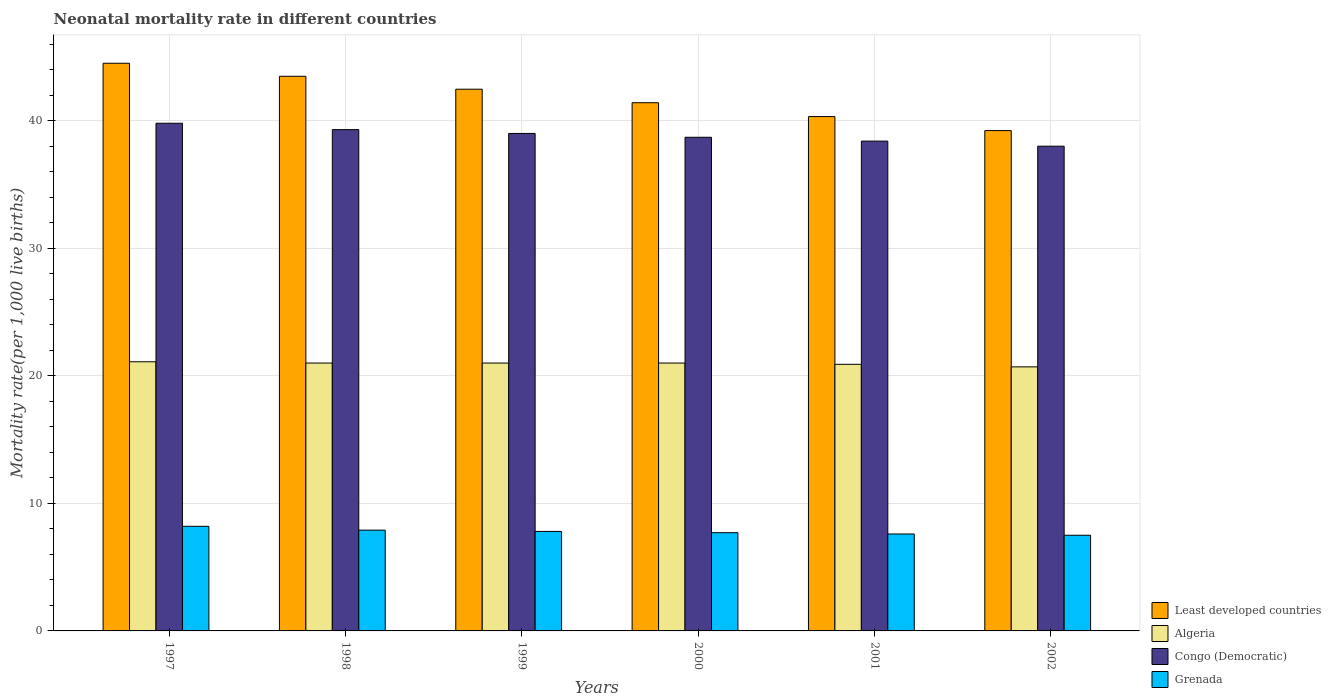How many groups of bars are there?
Your answer should be very brief. 6. Are the number of bars on each tick of the X-axis equal?
Offer a very short reply. Yes. In how many cases, is the number of bars for a given year not equal to the number of legend labels?
Provide a short and direct response. 0. Across all years, what is the minimum neonatal mortality rate in Least developed countries?
Provide a succinct answer. 39.22. In which year was the neonatal mortality rate in Algeria minimum?
Provide a succinct answer. 2002. What is the total neonatal mortality rate in Grenada in the graph?
Your answer should be compact. 46.7. What is the difference between the neonatal mortality rate in Congo (Democratic) in 2001 and that in 2002?
Ensure brevity in your answer.  0.4. What is the difference between the neonatal mortality rate in Congo (Democratic) in 2000 and the neonatal mortality rate in Least developed countries in 1997?
Offer a terse response. -5.8. What is the average neonatal mortality rate in Congo (Democratic) per year?
Your answer should be very brief. 38.87. In the year 2001, what is the difference between the neonatal mortality rate in Least developed countries and neonatal mortality rate in Algeria?
Make the answer very short. 19.42. In how many years, is the neonatal mortality rate in Algeria greater than 6?
Ensure brevity in your answer.  6. What is the ratio of the neonatal mortality rate in Congo (Democratic) in 1999 to that in 2000?
Provide a short and direct response. 1.01. Is the neonatal mortality rate in Least developed countries in 1997 less than that in 2000?
Provide a succinct answer. No. Is the difference between the neonatal mortality rate in Least developed countries in 2000 and 2001 greater than the difference between the neonatal mortality rate in Algeria in 2000 and 2001?
Keep it short and to the point. Yes. What is the difference between the highest and the second highest neonatal mortality rate in Algeria?
Keep it short and to the point. 0.1. What is the difference between the highest and the lowest neonatal mortality rate in Least developed countries?
Provide a succinct answer. 5.28. In how many years, is the neonatal mortality rate in Grenada greater than the average neonatal mortality rate in Grenada taken over all years?
Give a very brief answer. 3. What does the 3rd bar from the left in 1998 represents?
Give a very brief answer. Congo (Democratic). What does the 1st bar from the right in 1998 represents?
Ensure brevity in your answer.  Grenada. Are all the bars in the graph horizontal?
Provide a succinct answer. No. Does the graph contain any zero values?
Ensure brevity in your answer.  No. What is the title of the graph?
Your response must be concise. Neonatal mortality rate in different countries. What is the label or title of the X-axis?
Your response must be concise. Years. What is the label or title of the Y-axis?
Offer a terse response. Mortality rate(per 1,0 live births). What is the Mortality rate(per 1,000 live births) in Least developed countries in 1997?
Make the answer very short. 44.5. What is the Mortality rate(per 1,000 live births) of Algeria in 1997?
Your response must be concise. 21.1. What is the Mortality rate(per 1,000 live births) of Congo (Democratic) in 1997?
Your response must be concise. 39.8. What is the Mortality rate(per 1,000 live births) of Least developed countries in 1998?
Give a very brief answer. 43.48. What is the Mortality rate(per 1,000 live births) in Congo (Democratic) in 1998?
Provide a short and direct response. 39.3. What is the Mortality rate(per 1,000 live births) of Least developed countries in 1999?
Your response must be concise. 42.47. What is the Mortality rate(per 1,000 live births) in Least developed countries in 2000?
Make the answer very short. 41.41. What is the Mortality rate(per 1,000 live births) of Congo (Democratic) in 2000?
Offer a very short reply. 38.7. What is the Mortality rate(per 1,000 live births) of Least developed countries in 2001?
Ensure brevity in your answer.  40.32. What is the Mortality rate(per 1,000 live births) of Algeria in 2001?
Make the answer very short. 20.9. What is the Mortality rate(per 1,000 live births) in Congo (Democratic) in 2001?
Keep it short and to the point. 38.4. What is the Mortality rate(per 1,000 live births) of Grenada in 2001?
Ensure brevity in your answer.  7.6. What is the Mortality rate(per 1,000 live births) in Least developed countries in 2002?
Make the answer very short. 39.22. What is the Mortality rate(per 1,000 live births) in Algeria in 2002?
Make the answer very short. 20.7. What is the Mortality rate(per 1,000 live births) in Congo (Democratic) in 2002?
Offer a terse response. 38. Across all years, what is the maximum Mortality rate(per 1,000 live births) of Least developed countries?
Your response must be concise. 44.5. Across all years, what is the maximum Mortality rate(per 1,000 live births) in Algeria?
Provide a succinct answer. 21.1. Across all years, what is the maximum Mortality rate(per 1,000 live births) in Congo (Democratic)?
Provide a succinct answer. 39.8. Across all years, what is the maximum Mortality rate(per 1,000 live births) of Grenada?
Provide a short and direct response. 8.2. Across all years, what is the minimum Mortality rate(per 1,000 live births) in Least developed countries?
Ensure brevity in your answer.  39.22. Across all years, what is the minimum Mortality rate(per 1,000 live births) of Algeria?
Make the answer very short. 20.7. Across all years, what is the minimum Mortality rate(per 1,000 live births) of Grenada?
Provide a succinct answer. 7.5. What is the total Mortality rate(per 1,000 live births) of Least developed countries in the graph?
Offer a very short reply. 251.4. What is the total Mortality rate(per 1,000 live births) in Algeria in the graph?
Keep it short and to the point. 125.7. What is the total Mortality rate(per 1,000 live births) of Congo (Democratic) in the graph?
Ensure brevity in your answer.  233.2. What is the total Mortality rate(per 1,000 live births) in Grenada in the graph?
Your answer should be very brief. 46.7. What is the difference between the Mortality rate(per 1,000 live births) in Congo (Democratic) in 1997 and that in 1998?
Your response must be concise. 0.5. What is the difference between the Mortality rate(per 1,000 live births) of Grenada in 1997 and that in 1998?
Give a very brief answer. 0.3. What is the difference between the Mortality rate(per 1,000 live births) of Least developed countries in 1997 and that in 1999?
Your response must be concise. 2.03. What is the difference between the Mortality rate(per 1,000 live births) of Algeria in 1997 and that in 1999?
Make the answer very short. 0.1. What is the difference between the Mortality rate(per 1,000 live births) of Congo (Democratic) in 1997 and that in 1999?
Ensure brevity in your answer.  0.8. What is the difference between the Mortality rate(per 1,000 live births) of Least developed countries in 1997 and that in 2000?
Provide a succinct answer. 3.09. What is the difference between the Mortality rate(per 1,000 live births) in Grenada in 1997 and that in 2000?
Provide a succinct answer. 0.5. What is the difference between the Mortality rate(per 1,000 live births) of Least developed countries in 1997 and that in 2001?
Offer a terse response. 4.18. What is the difference between the Mortality rate(per 1,000 live births) of Congo (Democratic) in 1997 and that in 2001?
Provide a succinct answer. 1.4. What is the difference between the Mortality rate(per 1,000 live births) in Least developed countries in 1997 and that in 2002?
Make the answer very short. 5.28. What is the difference between the Mortality rate(per 1,000 live births) in Congo (Democratic) in 1997 and that in 2002?
Offer a very short reply. 1.8. What is the difference between the Mortality rate(per 1,000 live births) in Least developed countries in 1998 and that in 1999?
Your answer should be compact. 1.01. What is the difference between the Mortality rate(per 1,000 live births) of Algeria in 1998 and that in 1999?
Keep it short and to the point. 0. What is the difference between the Mortality rate(per 1,000 live births) in Congo (Democratic) in 1998 and that in 1999?
Your answer should be compact. 0.3. What is the difference between the Mortality rate(per 1,000 live births) in Grenada in 1998 and that in 1999?
Offer a very short reply. 0.1. What is the difference between the Mortality rate(per 1,000 live births) of Least developed countries in 1998 and that in 2000?
Make the answer very short. 2.07. What is the difference between the Mortality rate(per 1,000 live births) in Congo (Democratic) in 1998 and that in 2000?
Ensure brevity in your answer.  0.6. What is the difference between the Mortality rate(per 1,000 live births) in Least developed countries in 1998 and that in 2001?
Provide a succinct answer. 3.16. What is the difference between the Mortality rate(per 1,000 live births) in Algeria in 1998 and that in 2001?
Ensure brevity in your answer.  0.1. What is the difference between the Mortality rate(per 1,000 live births) in Grenada in 1998 and that in 2001?
Your response must be concise. 0.3. What is the difference between the Mortality rate(per 1,000 live births) of Least developed countries in 1998 and that in 2002?
Keep it short and to the point. 4.26. What is the difference between the Mortality rate(per 1,000 live births) of Congo (Democratic) in 1998 and that in 2002?
Ensure brevity in your answer.  1.3. What is the difference between the Mortality rate(per 1,000 live births) in Least developed countries in 1999 and that in 2000?
Provide a succinct answer. 1.06. What is the difference between the Mortality rate(per 1,000 live births) in Congo (Democratic) in 1999 and that in 2000?
Your answer should be compact. 0.3. What is the difference between the Mortality rate(per 1,000 live births) of Grenada in 1999 and that in 2000?
Keep it short and to the point. 0.1. What is the difference between the Mortality rate(per 1,000 live births) in Least developed countries in 1999 and that in 2001?
Provide a succinct answer. 2.15. What is the difference between the Mortality rate(per 1,000 live births) of Congo (Democratic) in 1999 and that in 2001?
Make the answer very short. 0.6. What is the difference between the Mortality rate(per 1,000 live births) in Least developed countries in 1999 and that in 2002?
Offer a terse response. 3.24. What is the difference between the Mortality rate(per 1,000 live births) of Algeria in 1999 and that in 2002?
Your answer should be compact. 0.3. What is the difference between the Mortality rate(per 1,000 live births) in Congo (Democratic) in 1999 and that in 2002?
Ensure brevity in your answer.  1. What is the difference between the Mortality rate(per 1,000 live births) in Least developed countries in 2000 and that in 2001?
Make the answer very short. 1.09. What is the difference between the Mortality rate(per 1,000 live births) in Grenada in 2000 and that in 2001?
Provide a short and direct response. 0.1. What is the difference between the Mortality rate(per 1,000 live births) in Least developed countries in 2000 and that in 2002?
Ensure brevity in your answer.  2.19. What is the difference between the Mortality rate(per 1,000 live births) of Algeria in 2000 and that in 2002?
Provide a succinct answer. 0.3. What is the difference between the Mortality rate(per 1,000 live births) of Congo (Democratic) in 2000 and that in 2002?
Provide a succinct answer. 0.7. What is the difference between the Mortality rate(per 1,000 live births) in Grenada in 2000 and that in 2002?
Ensure brevity in your answer.  0.2. What is the difference between the Mortality rate(per 1,000 live births) in Least developed countries in 2001 and that in 2002?
Provide a succinct answer. 1.1. What is the difference between the Mortality rate(per 1,000 live births) of Least developed countries in 1997 and the Mortality rate(per 1,000 live births) of Algeria in 1998?
Make the answer very short. 23.5. What is the difference between the Mortality rate(per 1,000 live births) in Least developed countries in 1997 and the Mortality rate(per 1,000 live births) in Congo (Democratic) in 1998?
Provide a succinct answer. 5.2. What is the difference between the Mortality rate(per 1,000 live births) in Least developed countries in 1997 and the Mortality rate(per 1,000 live births) in Grenada in 1998?
Provide a succinct answer. 36.6. What is the difference between the Mortality rate(per 1,000 live births) in Algeria in 1997 and the Mortality rate(per 1,000 live births) in Congo (Democratic) in 1998?
Your answer should be compact. -18.2. What is the difference between the Mortality rate(per 1,000 live births) in Algeria in 1997 and the Mortality rate(per 1,000 live births) in Grenada in 1998?
Your answer should be very brief. 13.2. What is the difference between the Mortality rate(per 1,000 live births) of Congo (Democratic) in 1997 and the Mortality rate(per 1,000 live births) of Grenada in 1998?
Offer a very short reply. 31.9. What is the difference between the Mortality rate(per 1,000 live births) in Least developed countries in 1997 and the Mortality rate(per 1,000 live births) in Algeria in 1999?
Ensure brevity in your answer.  23.5. What is the difference between the Mortality rate(per 1,000 live births) in Least developed countries in 1997 and the Mortality rate(per 1,000 live births) in Congo (Democratic) in 1999?
Offer a terse response. 5.5. What is the difference between the Mortality rate(per 1,000 live births) in Least developed countries in 1997 and the Mortality rate(per 1,000 live births) in Grenada in 1999?
Provide a short and direct response. 36.7. What is the difference between the Mortality rate(per 1,000 live births) of Algeria in 1997 and the Mortality rate(per 1,000 live births) of Congo (Democratic) in 1999?
Your answer should be very brief. -17.9. What is the difference between the Mortality rate(per 1,000 live births) of Algeria in 1997 and the Mortality rate(per 1,000 live births) of Grenada in 1999?
Keep it short and to the point. 13.3. What is the difference between the Mortality rate(per 1,000 live births) of Least developed countries in 1997 and the Mortality rate(per 1,000 live births) of Algeria in 2000?
Make the answer very short. 23.5. What is the difference between the Mortality rate(per 1,000 live births) in Least developed countries in 1997 and the Mortality rate(per 1,000 live births) in Congo (Democratic) in 2000?
Offer a very short reply. 5.8. What is the difference between the Mortality rate(per 1,000 live births) in Least developed countries in 1997 and the Mortality rate(per 1,000 live births) in Grenada in 2000?
Provide a succinct answer. 36.8. What is the difference between the Mortality rate(per 1,000 live births) in Algeria in 1997 and the Mortality rate(per 1,000 live births) in Congo (Democratic) in 2000?
Offer a very short reply. -17.6. What is the difference between the Mortality rate(per 1,000 live births) in Algeria in 1997 and the Mortality rate(per 1,000 live births) in Grenada in 2000?
Provide a short and direct response. 13.4. What is the difference between the Mortality rate(per 1,000 live births) of Congo (Democratic) in 1997 and the Mortality rate(per 1,000 live births) of Grenada in 2000?
Keep it short and to the point. 32.1. What is the difference between the Mortality rate(per 1,000 live births) of Least developed countries in 1997 and the Mortality rate(per 1,000 live births) of Algeria in 2001?
Give a very brief answer. 23.6. What is the difference between the Mortality rate(per 1,000 live births) in Least developed countries in 1997 and the Mortality rate(per 1,000 live births) in Congo (Democratic) in 2001?
Your answer should be compact. 6.1. What is the difference between the Mortality rate(per 1,000 live births) of Least developed countries in 1997 and the Mortality rate(per 1,000 live births) of Grenada in 2001?
Your response must be concise. 36.9. What is the difference between the Mortality rate(per 1,000 live births) of Algeria in 1997 and the Mortality rate(per 1,000 live births) of Congo (Democratic) in 2001?
Give a very brief answer. -17.3. What is the difference between the Mortality rate(per 1,000 live births) in Algeria in 1997 and the Mortality rate(per 1,000 live births) in Grenada in 2001?
Give a very brief answer. 13.5. What is the difference between the Mortality rate(per 1,000 live births) in Congo (Democratic) in 1997 and the Mortality rate(per 1,000 live births) in Grenada in 2001?
Your answer should be very brief. 32.2. What is the difference between the Mortality rate(per 1,000 live births) in Least developed countries in 1997 and the Mortality rate(per 1,000 live births) in Algeria in 2002?
Your answer should be very brief. 23.8. What is the difference between the Mortality rate(per 1,000 live births) in Least developed countries in 1997 and the Mortality rate(per 1,000 live births) in Congo (Democratic) in 2002?
Provide a succinct answer. 6.5. What is the difference between the Mortality rate(per 1,000 live births) of Least developed countries in 1997 and the Mortality rate(per 1,000 live births) of Grenada in 2002?
Offer a terse response. 37. What is the difference between the Mortality rate(per 1,000 live births) of Algeria in 1997 and the Mortality rate(per 1,000 live births) of Congo (Democratic) in 2002?
Make the answer very short. -16.9. What is the difference between the Mortality rate(per 1,000 live births) in Algeria in 1997 and the Mortality rate(per 1,000 live births) in Grenada in 2002?
Provide a succinct answer. 13.6. What is the difference between the Mortality rate(per 1,000 live births) in Congo (Democratic) in 1997 and the Mortality rate(per 1,000 live births) in Grenada in 2002?
Your answer should be very brief. 32.3. What is the difference between the Mortality rate(per 1,000 live births) of Least developed countries in 1998 and the Mortality rate(per 1,000 live births) of Algeria in 1999?
Provide a short and direct response. 22.48. What is the difference between the Mortality rate(per 1,000 live births) of Least developed countries in 1998 and the Mortality rate(per 1,000 live births) of Congo (Democratic) in 1999?
Your answer should be very brief. 4.48. What is the difference between the Mortality rate(per 1,000 live births) in Least developed countries in 1998 and the Mortality rate(per 1,000 live births) in Grenada in 1999?
Your answer should be very brief. 35.68. What is the difference between the Mortality rate(per 1,000 live births) in Algeria in 1998 and the Mortality rate(per 1,000 live births) in Grenada in 1999?
Provide a short and direct response. 13.2. What is the difference between the Mortality rate(per 1,000 live births) in Congo (Democratic) in 1998 and the Mortality rate(per 1,000 live births) in Grenada in 1999?
Make the answer very short. 31.5. What is the difference between the Mortality rate(per 1,000 live births) of Least developed countries in 1998 and the Mortality rate(per 1,000 live births) of Algeria in 2000?
Keep it short and to the point. 22.48. What is the difference between the Mortality rate(per 1,000 live births) in Least developed countries in 1998 and the Mortality rate(per 1,000 live births) in Congo (Democratic) in 2000?
Offer a very short reply. 4.78. What is the difference between the Mortality rate(per 1,000 live births) of Least developed countries in 1998 and the Mortality rate(per 1,000 live births) of Grenada in 2000?
Provide a succinct answer. 35.78. What is the difference between the Mortality rate(per 1,000 live births) of Algeria in 1998 and the Mortality rate(per 1,000 live births) of Congo (Democratic) in 2000?
Give a very brief answer. -17.7. What is the difference between the Mortality rate(per 1,000 live births) of Algeria in 1998 and the Mortality rate(per 1,000 live births) of Grenada in 2000?
Ensure brevity in your answer.  13.3. What is the difference between the Mortality rate(per 1,000 live births) in Congo (Democratic) in 1998 and the Mortality rate(per 1,000 live births) in Grenada in 2000?
Your answer should be very brief. 31.6. What is the difference between the Mortality rate(per 1,000 live births) of Least developed countries in 1998 and the Mortality rate(per 1,000 live births) of Algeria in 2001?
Your answer should be very brief. 22.58. What is the difference between the Mortality rate(per 1,000 live births) of Least developed countries in 1998 and the Mortality rate(per 1,000 live births) of Congo (Democratic) in 2001?
Your answer should be very brief. 5.08. What is the difference between the Mortality rate(per 1,000 live births) in Least developed countries in 1998 and the Mortality rate(per 1,000 live births) in Grenada in 2001?
Your response must be concise. 35.88. What is the difference between the Mortality rate(per 1,000 live births) in Algeria in 1998 and the Mortality rate(per 1,000 live births) in Congo (Democratic) in 2001?
Provide a succinct answer. -17.4. What is the difference between the Mortality rate(per 1,000 live births) in Congo (Democratic) in 1998 and the Mortality rate(per 1,000 live births) in Grenada in 2001?
Your answer should be compact. 31.7. What is the difference between the Mortality rate(per 1,000 live births) in Least developed countries in 1998 and the Mortality rate(per 1,000 live births) in Algeria in 2002?
Offer a terse response. 22.78. What is the difference between the Mortality rate(per 1,000 live births) in Least developed countries in 1998 and the Mortality rate(per 1,000 live births) in Congo (Democratic) in 2002?
Your answer should be very brief. 5.48. What is the difference between the Mortality rate(per 1,000 live births) in Least developed countries in 1998 and the Mortality rate(per 1,000 live births) in Grenada in 2002?
Your response must be concise. 35.98. What is the difference between the Mortality rate(per 1,000 live births) in Congo (Democratic) in 1998 and the Mortality rate(per 1,000 live births) in Grenada in 2002?
Your answer should be compact. 31.8. What is the difference between the Mortality rate(per 1,000 live births) of Least developed countries in 1999 and the Mortality rate(per 1,000 live births) of Algeria in 2000?
Give a very brief answer. 21.47. What is the difference between the Mortality rate(per 1,000 live births) in Least developed countries in 1999 and the Mortality rate(per 1,000 live births) in Congo (Democratic) in 2000?
Provide a succinct answer. 3.77. What is the difference between the Mortality rate(per 1,000 live births) of Least developed countries in 1999 and the Mortality rate(per 1,000 live births) of Grenada in 2000?
Provide a succinct answer. 34.77. What is the difference between the Mortality rate(per 1,000 live births) in Algeria in 1999 and the Mortality rate(per 1,000 live births) in Congo (Democratic) in 2000?
Give a very brief answer. -17.7. What is the difference between the Mortality rate(per 1,000 live births) in Congo (Democratic) in 1999 and the Mortality rate(per 1,000 live births) in Grenada in 2000?
Offer a terse response. 31.3. What is the difference between the Mortality rate(per 1,000 live births) in Least developed countries in 1999 and the Mortality rate(per 1,000 live births) in Algeria in 2001?
Make the answer very short. 21.57. What is the difference between the Mortality rate(per 1,000 live births) of Least developed countries in 1999 and the Mortality rate(per 1,000 live births) of Congo (Democratic) in 2001?
Ensure brevity in your answer.  4.07. What is the difference between the Mortality rate(per 1,000 live births) in Least developed countries in 1999 and the Mortality rate(per 1,000 live births) in Grenada in 2001?
Provide a succinct answer. 34.87. What is the difference between the Mortality rate(per 1,000 live births) in Algeria in 1999 and the Mortality rate(per 1,000 live births) in Congo (Democratic) in 2001?
Make the answer very short. -17.4. What is the difference between the Mortality rate(per 1,000 live births) in Algeria in 1999 and the Mortality rate(per 1,000 live births) in Grenada in 2001?
Your answer should be compact. 13.4. What is the difference between the Mortality rate(per 1,000 live births) in Congo (Democratic) in 1999 and the Mortality rate(per 1,000 live births) in Grenada in 2001?
Your answer should be compact. 31.4. What is the difference between the Mortality rate(per 1,000 live births) of Least developed countries in 1999 and the Mortality rate(per 1,000 live births) of Algeria in 2002?
Provide a succinct answer. 21.77. What is the difference between the Mortality rate(per 1,000 live births) in Least developed countries in 1999 and the Mortality rate(per 1,000 live births) in Congo (Democratic) in 2002?
Offer a very short reply. 4.47. What is the difference between the Mortality rate(per 1,000 live births) of Least developed countries in 1999 and the Mortality rate(per 1,000 live births) of Grenada in 2002?
Ensure brevity in your answer.  34.97. What is the difference between the Mortality rate(per 1,000 live births) in Algeria in 1999 and the Mortality rate(per 1,000 live births) in Congo (Democratic) in 2002?
Provide a succinct answer. -17. What is the difference between the Mortality rate(per 1,000 live births) of Algeria in 1999 and the Mortality rate(per 1,000 live births) of Grenada in 2002?
Offer a terse response. 13.5. What is the difference between the Mortality rate(per 1,000 live births) in Congo (Democratic) in 1999 and the Mortality rate(per 1,000 live births) in Grenada in 2002?
Make the answer very short. 31.5. What is the difference between the Mortality rate(per 1,000 live births) of Least developed countries in 2000 and the Mortality rate(per 1,000 live births) of Algeria in 2001?
Your answer should be very brief. 20.51. What is the difference between the Mortality rate(per 1,000 live births) of Least developed countries in 2000 and the Mortality rate(per 1,000 live births) of Congo (Democratic) in 2001?
Provide a short and direct response. 3.01. What is the difference between the Mortality rate(per 1,000 live births) of Least developed countries in 2000 and the Mortality rate(per 1,000 live births) of Grenada in 2001?
Offer a terse response. 33.81. What is the difference between the Mortality rate(per 1,000 live births) of Algeria in 2000 and the Mortality rate(per 1,000 live births) of Congo (Democratic) in 2001?
Keep it short and to the point. -17.4. What is the difference between the Mortality rate(per 1,000 live births) in Congo (Democratic) in 2000 and the Mortality rate(per 1,000 live births) in Grenada in 2001?
Keep it short and to the point. 31.1. What is the difference between the Mortality rate(per 1,000 live births) of Least developed countries in 2000 and the Mortality rate(per 1,000 live births) of Algeria in 2002?
Your answer should be compact. 20.71. What is the difference between the Mortality rate(per 1,000 live births) in Least developed countries in 2000 and the Mortality rate(per 1,000 live births) in Congo (Democratic) in 2002?
Keep it short and to the point. 3.41. What is the difference between the Mortality rate(per 1,000 live births) in Least developed countries in 2000 and the Mortality rate(per 1,000 live births) in Grenada in 2002?
Ensure brevity in your answer.  33.91. What is the difference between the Mortality rate(per 1,000 live births) in Algeria in 2000 and the Mortality rate(per 1,000 live births) in Grenada in 2002?
Offer a very short reply. 13.5. What is the difference between the Mortality rate(per 1,000 live births) of Congo (Democratic) in 2000 and the Mortality rate(per 1,000 live births) of Grenada in 2002?
Ensure brevity in your answer.  31.2. What is the difference between the Mortality rate(per 1,000 live births) in Least developed countries in 2001 and the Mortality rate(per 1,000 live births) in Algeria in 2002?
Your answer should be compact. 19.62. What is the difference between the Mortality rate(per 1,000 live births) in Least developed countries in 2001 and the Mortality rate(per 1,000 live births) in Congo (Democratic) in 2002?
Ensure brevity in your answer.  2.32. What is the difference between the Mortality rate(per 1,000 live births) in Least developed countries in 2001 and the Mortality rate(per 1,000 live births) in Grenada in 2002?
Offer a very short reply. 32.82. What is the difference between the Mortality rate(per 1,000 live births) in Algeria in 2001 and the Mortality rate(per 1,000 live births) in Congo (Democratic) in 2002?
Your response must be concise. -17.1. What is the difference between the Mortality rate(per 1,000 live births) in Algeria in 2001 and the Mortality rate(per 1,000 live births) in Grenada in 2002?
Give a very brief answer. 13.4. What is the difference between the Mortality rate(per 1,000 live births) in Congo (Democratic) in 2001 and the Mortality rate(per 1,000 live births) in Grenada in 2002?
Keep it short and to the point. 30.9. What is the average Mortality rate(per 1,000 live births) of Least developed countries per year?
Offer a terse response. 41.9. What is the average Mortality rate(per 1,000 live births) of Algeria per year?
Provide a succinct answer. 20.95. What is the average Mortality rate(per 1,000 live births) in Congo (Democratic) per year?
Offer a terse response. 38.87. What is the average Mortality rate(per 1,000 live births) of Grenada per year?
Ensure brevity in your answer.  7.78. In the year 1997, what is the difference between the Mortality rate(per 1,000 live births) in Least developed countries and Mortality rate(per 1,000 live births) in Algeria?
Your response must be concise. 23.4. In the year 1997, what is the difference between the Mortality rate(per 1,000 live births) of Least developed countries and Mortality rate(per 1,000 live births) of Congo (Democratic)?
Your response must be concise. 4.7. In the year 1997, what is the difference between the Mortality rate(per 1,000 live births) in Least developed countries and Mortality rate(per 1,000 live births) in Grenada?
Keep it short and to the point. 36.3. In the year 1997, what is the difference between the Mortality rate(per 1,000 live births) in Algeria and Mortality rate(per 1,000 live births) in Congo (Democratic)?
Give a very brief answer. -18.7. In the year 1997, what is the difference between the Mortality rate(per 1,000 live births) of Algeria and Mortality rate(per 1,000 live births) of Grenada?
Provide a short and direct response. 12.9. In the year 1997, what is the difference between the Mortality rate(per 1,000 live births) of Congo (Democratic) and Mortality rate(per 1,000 live births) of Grenada?
Give a very brief answer. 31.6. In the year 1998, what is the difference between the Mortality rate(per 1,000 live births) of Least developed countries and Mortality rate(per 1,000 live births) of Algeria?
Make the answer very short. 22.48. In the year 1998, what is the difference between the Mortality rate(per 1,000 live births) in Least developed countries and Mortality rate(per 1,000 live births) in Congo (Democratic)?
Give a very brief answer. 4.18. In the year 1998, what is the difference between the Mortality rate(per 1,000 live births) in Least developed countries and Mortality rate(per 1,000 live births) in Grenada?
Your response must be concise. 35.58. In the year 1998, what is the difference between the Mortality rate(per 1,000 live births) in Algeria and Mortality rate(per 1,000 live births) in Congo (Democratic)?
Keep it short and to the point. -18.3. In the year 1998, what is the difference between the Mortality rate(per 1,000 live births) in Congo (Democratic) and Mortality rate(per 1,000 live births) in Grenada?
Ensure brevity in your answer.  31.4. In the year 1999, what is the difference between the Mortality rate(per 1,000 live births) of Least developed countries and Mortality rate(per 1,000 live births) of Algeria?
Provide a succinct answer. 21.47. In the year 1999, what is the difference between the Mortality rate(per 1,000 live births) of Least developed countries and Mortality rate(per 1,000 live births) of Congo (Democratic)?
Your answer should be compact. 3.47. In the year 1999, what is the difference between the Mortality rate(per 1,000 live births) in Least developed countries and Mortality rate(per 1,000 live births) in Grenada?
Offer a terse response. 34.67. In the year 1999, what is the difference between the Mortality rate(per 1,000 live births) in Algeria and Mortality rate(per 1,000 live births) in Congo (Democratic)?
Offer a very short reply. -18. In the year 1999, what is the difference between the Mortality rate(per 1,000 live births) in Congo (Democratic) and Mortality rate(per 1,000 live births) in Grenada?
Provide a short and direct response. 31.2. In the year 2000, what is the difference between the Mortality rate(per 1,000 live births) of Least developed countries and Mortality rate(per 1,000 live births) of Algeria?
Offer a terse response. 20.41. In the year 2000, what is the difference between the Mortality rate(per 1,000 live births) in Least developed countries and Mortality rate(per 1,000 live births) in Congo (Democratic)?
Offer a terse response. 2.71. In the year 2000, what is the difference between the Mortality rate(per 1,000 live births) in Least developed countries and Mortality rate(per 1,000 live births) in Grenada?
Your answer should be very brief. 33.71. In the year 2000, what is the difference between the Mortality rate(per 1,000 live births) in Algeria and Mortality rate(per 1,000 live births) in Congo (Democratic)?
Give a very brief answer. -17.7. In the year 2001, what is the difference between the Mortality rate(per 1,000 live births) of Least developed countries and Mortality rate(per 1,000 live births) of Algeria?
Ensure brevity in your answer.  19.42. In the year 2001, what is the difference between the Mortality rate(per 1,000 live births) of Least developed countries and Mortality rate(per 1,000 live births) of Congo (Democratic)?
Your response must be concise. 1.92. In the year 2001, what is the difference between the Mortality rate(per 1,000 live births) in Least developed countries and Mortality rate(per 1,000 live births) in Grenada?
Your answer should be compact. 32.72. In the year 2001, what is the difference between the Mortality rate(per 1,000 live births) of Algeria and Mortality rate(per 1,000 live births) of Congo (Democratic)?
Make the answer very short. -17.5. In the year 2001, what is the difference between the Mortality rate(per 1,000 live births) of Algeria and Mortality rate(per 1,000 live births) of Grenada?
Offer a terse response. 13.3. In the year 2001, what is the difference between the Mortality rate(per 1,000 live births) of Congo (Democratic) and Mortality rate(per 1,000 live births) of Grenada?
Your response must be concise. 30.8. In the year 2002, what is the difference between the Mortality rate(per 1,000 live births) of Least developed countries and Mortality rate(per 1,000 live births) of Algeria?
Give a very brief answer. 18.52. In the year 2002, what is the difference between the Mortality rate(per 1,000 live births) of Least developed countries and Mortality rate(per 1,000 live births) of Congo (Democratic)?
Your answer should be very brief. 1.22. In the year 2002, what is the difference between the Mortality rate(per 1,000 live births) in Least developed countries and Mortality rate(per 1,000 live births) in Grenada?
Ensure brevity in your answer.  31.72. In the year 2002, what is the difference between the Mortality rate(per 1,000 live births) of Algeria and Mortality rate(per 1,000 live births) of Congo (Democratic)?
Offer a terse response. -17.3. In the year 2002, what is the difference between the Mortality rate(per 1,000 live births) in Algeria and Mortality rate(per 1,000 live births) in Grenada?
Give a very brief answer. 13.2. In the year 2002, what is the difference between the Mortality rate(per 1,000 live births) in Congo (Democratic) and Mortality rate(per 1,000 live births) in Grenada?
Offer a very short reply. 30.5. What is the ratio of the Mortality rate(per 1,000 live births) in Least developed countries in 1997 to that in 1998?
Keep it short and to the point. 1.02. What is the ratio of the Mortality rate(per 1,000 live births) of Congo (Democratic) in 1997 to that in 1998?
Give a very brief answer. 1.01. What is the ratio of the Mortality rate(per 1,000 live births) of Grenada in 1997 to that in 1998?
Offer a terse response. 1.04. What is the ratio of the Mortality rate(per 1,000 live births) of Least developed countries in 1997 to that in 1999?
Provide a succinct answer. 1.05. What is the ratio of the Mortality rate(per 1,000 live births) in Algeria in 1997 to that in 1999?
Provide a short and direct response. 1. What is the ratio of the Mortality rate(per 1,000 live births) in Congo (Democratic) in 1997 to that in 1999?
Your answer should be compact. 1.02. What is the ratio of the Mortality rate(per 1,000 live births) of Grenada in 1997 to that in 1999?
Your answer should be compact. 1.05. What is the ratio of the Mortality rate(per 1,000 live births) of Least developed countries in 1997 to that in 2000?
Make the answer very short. 1.07. What is the ratio of the Mortality rate(per 1,000 live births) of Congo (Democratic) in 1997 to that in 2000?
Your response must be concise. 1.03. What is the ratio of the Mortality rate(per 1,000 live births) in Grenada in 1997 to that in 2000?
Make the answer very short. 1.06. What is the ratio of the Mortality rate(per 1,000 live births) of Least developed countries in 1997 to that in 2001?
Make the answer very short. 1.1. What is the ratio of the Mortality rate(per 1,000 live births) in Algeria in 1997 to that in 2001?
Offer a terse response. 1.01. What is the ratio of the Mortality rate(per 1,000 live births) in Congo (Democratic) in 1997 to that in 2001?
Provide a short and direct response. 1.04. What is the ratio of the Mortality rate(per 1,000 live births) of Grenada in 1997 to that in 2001?
Make the answer very short. 1.08. What is the ratio of the Mortality rate(per 1,000 live births) in Least developed countries in 1997 to that in 2002?
Your answer should be very brief. 1.13. What is the ratio of the Mortality rate(per 1,000 live births) of Algeria in 1997 to that in 2002?
Ensure brevity in your answer.  1.02. What is the ratio of the Mortality rate(per 1,000 live births) of Congo (Democratic) in 1997 to that in 2002?
Provide a succinct answer. 1.05. What is the ratio of the Mortality rate(per 1,000 live births) in Grenada in 1997 to that in 2002?
Keep it short and to the point. 1.09. What is the ratio of the Mortality rate(per 1,000 live births) in Least developed countries in 1998 to that in 1999?
Keep it short and to the point. 1.02. What is the ratio of the Mortality rate(per 1,000 live births) in Congo (Democratic) in 1998 to that in 1999?
Offer a very short reply. 1.01. What is the ratio of the Mortality rate(per 1,000 live births) in Grenada in 1998 to that in 1999?
Offer a terse response. 1.01. What is the ratio of the Mortality rate(per 1,000 live births) of Least developed countries in 1998 to that in 2000?
Your answer should be compact. 1.05. What is the ratio of the Mortality rate(per 1,000 live births) in Algeria in 1998 to that in 2000?
Make the answer very short. 1. What is the ratio of the Mortality rate(per 1,000 live births) in Congo (Democratic) in 1998 to that in 2000?
Offer a very short reply. 1.02. What is the ratio of the Mortality rate(per 1,000 live births) of Least developed countries in 1998 to that in 2001?
Provide a short and direct response. 1.08. What is the ratio of the Mortality rate(per 1,000 live births) of Congo (Democratic) in 1998 to that in 2001?
Provide a short and direct response. 1.02. What is the ratio of the Mortality rate(per 1,000 live births) in Grenada in 1998 to that in 2001?
Your answer should be very brief. 1.04. What is the ratio of the Mortality rate(per 1,000 live births) of Least developed countries in 1998 to that in 2002?
Your answer should be compact. 1.11. What is the ratio of the Mortality rate(per 1,000 live births) in Algeria in 1998 to that in 2002?
Ensure brevity in your answer.  1.01. What is the ratio of the Mortality rate(per 1,000 live births) of Congo (Democratic) in 1998 to that in 2002?
Keep it short and to the point. 1.03. What is the ratio of the Mortality rate(per 1,000 live births) in Grenada in 1998 to that in 2002?
Your answer should be compact. 1.05. What is the ratio of the Mortality rate(per 1,000 live births) in Least developed countries in 1999 to that in 2000?
Ensure brevity in your answer.  1.03. What is the ratio of the Mortality rate(per 1,000 live births) in Algeria in 1999 to that in 2000?
Your answer should be compact. 1. What is the ratio of the Mortality rate(per 1,000 live births) in Congo (Democratic) in 1999 to that in 2000?
Your answer should be very brief. 1.01. What is the ratio of the Mortality rate(per 1,000 live births) in Grenada in 1999 to that in 2000?
Make the answer very short. 1.01. What is the ratio of the Mortality rate(per 1,000 live births) in Least developed countries in 1999 to that in 2001?
Offer a very short reply. 1.05. What is the ratio of the Mortality rate(per 1,000 live births) in Algeria in 1999 to that in 2001?
Your answer should be very brief. 1. What is the ratio of the Mortality rate(per 1,000 live births) in Congo (Democratic) in 1999 to that in 2001?
Your response must be concise. 1.02. What is the ratio of the Mortality rate(per 1,000 live births) in Grenada in 1999 to that in 2001?
Give a very brief answer. 1.03. What is the ratio of the Mortality rate(per 1,000 live births) of Least developed countries in 1999 to that in 2002?
Ensure brevity in your answer.  1.08. What is the ratio of the Mortality rate(per 1,000 live births) in Algeria in 1999 to that in 2002?
Offer a terse response. 1.01. What is the ratio of the Mortality rate(per 1,000 live births) of Congo (Democratic) in 1999 to that in 2002?
Provide a succinct answer. 1.03. What is the ratio of the Mortality rate(per 1,000 live births) in Grenada in 1999 to that in 2002?
Make the answer very short. 1.04. What is the ratio of the Mortality rate(per 1,000 live births) of Least developed countries in 2000 to that in 2001?
Provide a short and direct response. 1.03. What is the ratio of the Mortality rate(per 1,000 live births) in Algeria in 2000 to that in 2001?
Offer a very short reply. 1. What is the ratio of the Mortality rate(per 1,000 live births) of Grenada in 2000 to that in 2001?
Provide a succinct answer. 1.01. What is the ratio of the Mortality rate(per 1,000 live births) in Least developed countries in 2000 to that in 2002?
Offer a terse response. 1.06. What is the ratio of the Mortality rate(per 1,000 live births) of Algeria in 2000 to that in 2002?
Your response must be concise. 1.01. What is the ratio of the Mortality rate(per 1,000 live births) in Congo (Democratic) in 2000 to that in 2002?
Your answer should be very brief. 1.02. What is the ratio of the Mortality rate(per 1,000 live births) in Grenada in 2000 to that in 2002?
Your answer should be very brief. 1.03. What is the ratio of the Mortality rate(per 1,000 live births) in Least developed countries in 2001 to that in 2002?
Keep it short and to the point. 1.03. What is the ratio of the Mortality rate(per 1,000 live births) of Algeria in 2001 to that in 2002?
Make the answer very short. 1.01. What is the ratio of the Mortality rate(per 1,000 live births) of Congo (Democratic) in 2001 to that in 2002?
Provide a short and direct response. 1.01. What is the ratio of the Mortality rate(per 1,000 live births) in Grenada in 2001 to that in 2002?
Offer a very short reply. 1.01. What is the difference between the highest and the second highest Mortality rate(per 1,000 live births) in Grenada?
Keep it short and to the point. 0.3. What is the difference between the highest and the lowest Mortality rate(per 1,000 live births) of Least developed countries?
Your response must be concise. 5.28. What is the difference between the highest and the lowest Mortality rate(per 1,000 live births) in Grenada?
Make the answer very short. 0.7. 